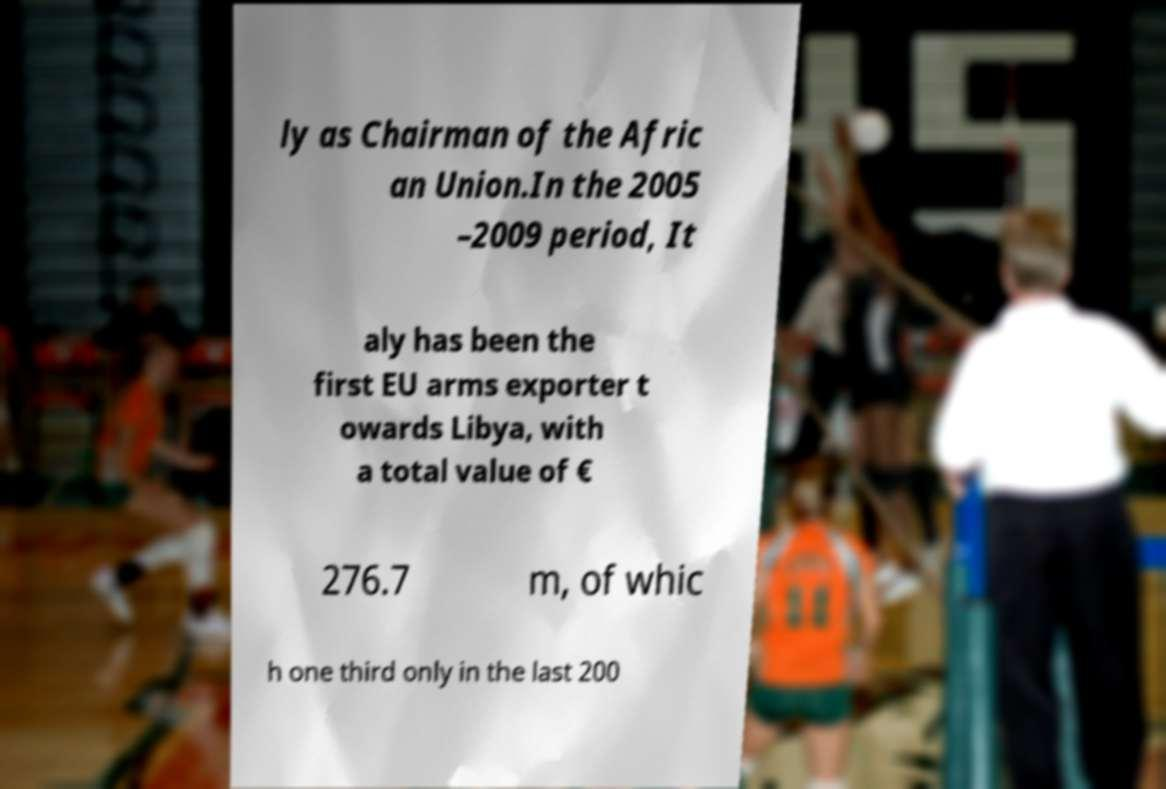For documentation purposes, I need the text within this image transcribed. Could you provide that? ly as Chairman of the Afric an Union.In the 2005 –2009 period, It aly has been the first EU arms exporter t owards Libya, with a total value of € 276.7 m, of whic h one third only in the last 200 